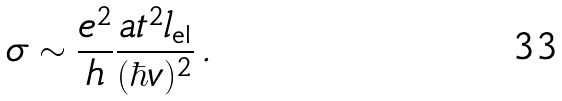<formula> <loc_0><loc_0><loc_500><loc_500>\sigma \sim \frac { e ^ { 2 } } { h } \frac { a t ^ { 2 } l _ { \text {el} } } { ( \hbar { v } ) ^ { 2 } } \, .</formula> 